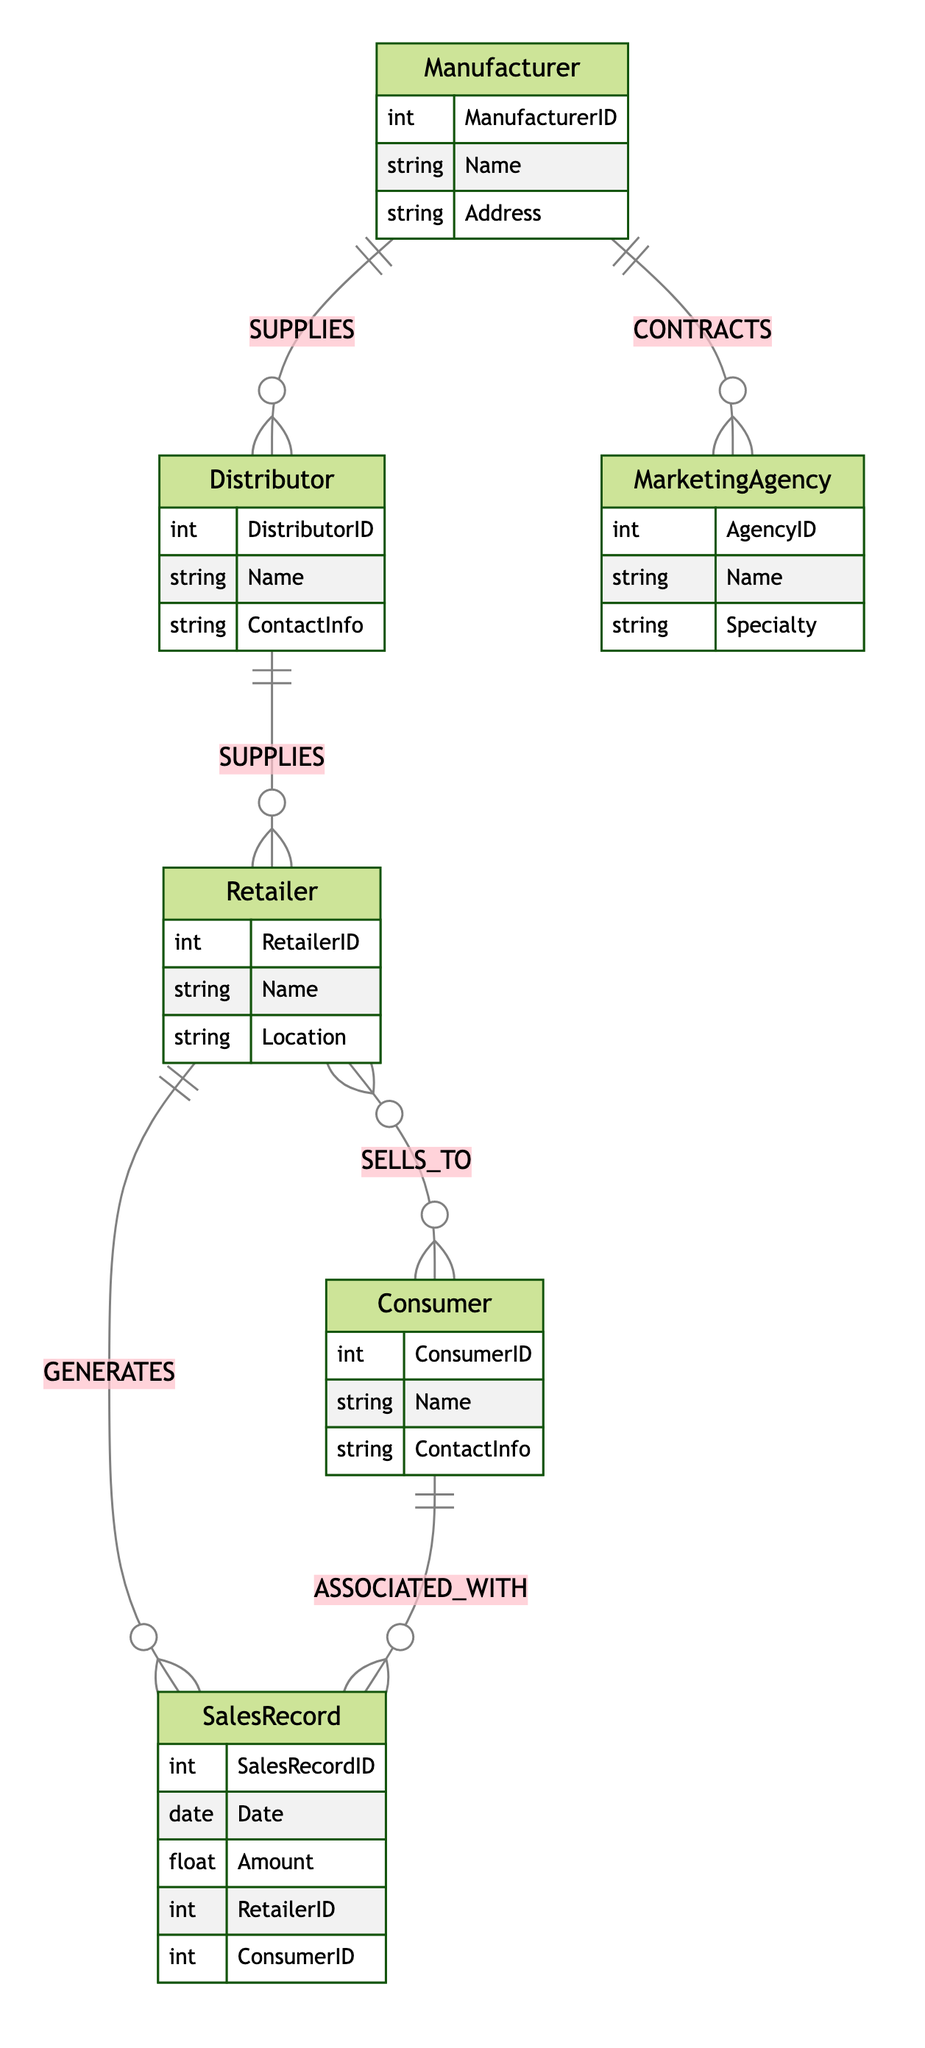What is the relationship between Manufacturer and Distributor? The diagram shows that the Manufacturer has a "SUPPLIES" relationship with the Distributor, indicating that Manufacturers provide products to Distributors.
Answer: SUPPLIES How many attributes does the Retailer entity have? The Retailer entity has three attributes: RetailerID, Name, and Location, as listed in the diagram's entity section.
Answer: 3 What type of relationship exists between Retailer and Consumer? The diagram illustrates a "SELLS_TO" relationship between Retailer and Consumer, which signifies that Retailers sell to Consumers.
Answer: SELLS_TO How many Sales Records can a Retailer generate? According to the diagram, a Retailer can generate many Sales Records based on the "GENERATES" relationship shown, indicating that a single Retailer can be linked to multiple Sales Records.
Answer: many Which entity is contracted by a Manufacturer? The diagram indicates that a Manufacturer is "CONTRACTED_BY" a Marketing Agency, meaning that Manufacturers hire Marketing Agencies for promotional activities.
Answer: Marketing Agency What is the minimum number of Distributors per Manufacturer? The "SUPPLIES" relationship from Manufacturer to Distributor is defined as "1 to many," which means each Manufacturer must have at least one Distributor to supply their products.
Answer: 1 What does the Consumer do to the Retailer? The diagram describes that Consumers "BUYS_FROM" Retailers, which establishes the consumers' role in purchasing products from retailers.
Answer: BUYS_FROM How is a Sales Record associated with the Consumer? The diagram describes that each Sales Record is "ASSOCIATED_WITH" a Consumer, indicating that every Sales Record must relate to one specific Consumer.
Answer: ASSOCIATED_WITH What can be said about the relationship between Distributor and Retailer? The Distributor has a "SUPPLIES" relationship with the Retailer, meaning that Distributors also supply products to Retailers, similar to the relationship between Manufacturer and Distributor.
Answer: SUPPLIES 